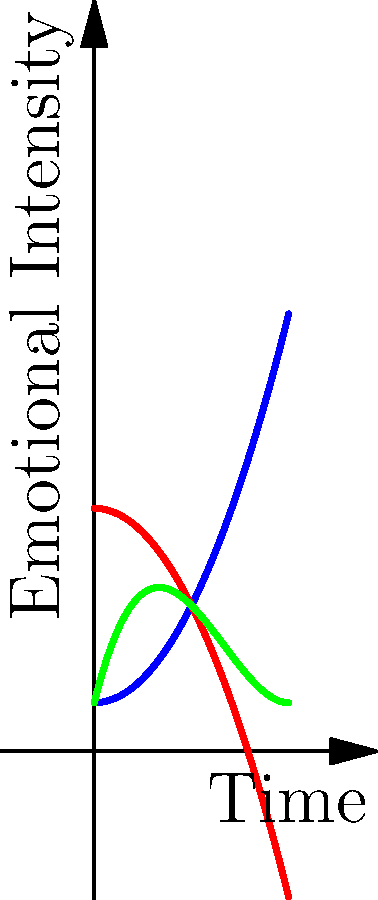In the graph above, three curves represent the emotional progression of different characters in a manga storyline over time. Which character experiences the most dramatic emotional shift, and at what point in the timeline does this occur? To determine which character experiences the most dramatic emotional shift, we need to analyze the curves for each character:

1. Character A (blue curve): Shows a steady increase in emotional intensity over time.
2. Character B (red curve): Displays a gradual decrease in emotional intensity.
3. Character C (green curve): Exhibits a more complex emotional journey.

To find the most dramatic shift, we need to look for the steepest slope on any of the curves:

1. Calculate the derivative of each function to find the rate of change:
   A: $f'_1(x) = x$
   B: $f'_2(x) = -x$
   C: $f'_3(x) = 0.75x^2 - 4x + 4$

2. Analyze the derivatives:
   A and B have linear derivatives, meaning constant rate of change.
   C has a quadratic derivative, indicating varying rates of change.

3. Find the maximum absolute value of the derivative for C:
   Set $f'_3(x) = 0$ and solve:
   $0.75x^2 - 4x + 4 = 0$
   $x = 2.67$ or $x = 2$

4. The steepest slope for C occurs at $x = 2.67$, which is the point of most dramatic change.

5. Compare this with the constant slopes of A and B, which are less steep.

Therefore, Character C experiences the most dramatic emotional shift at approximately $x = 2.67$ on the timeline.
Answer: Character C at $x \approx 2.67$ 